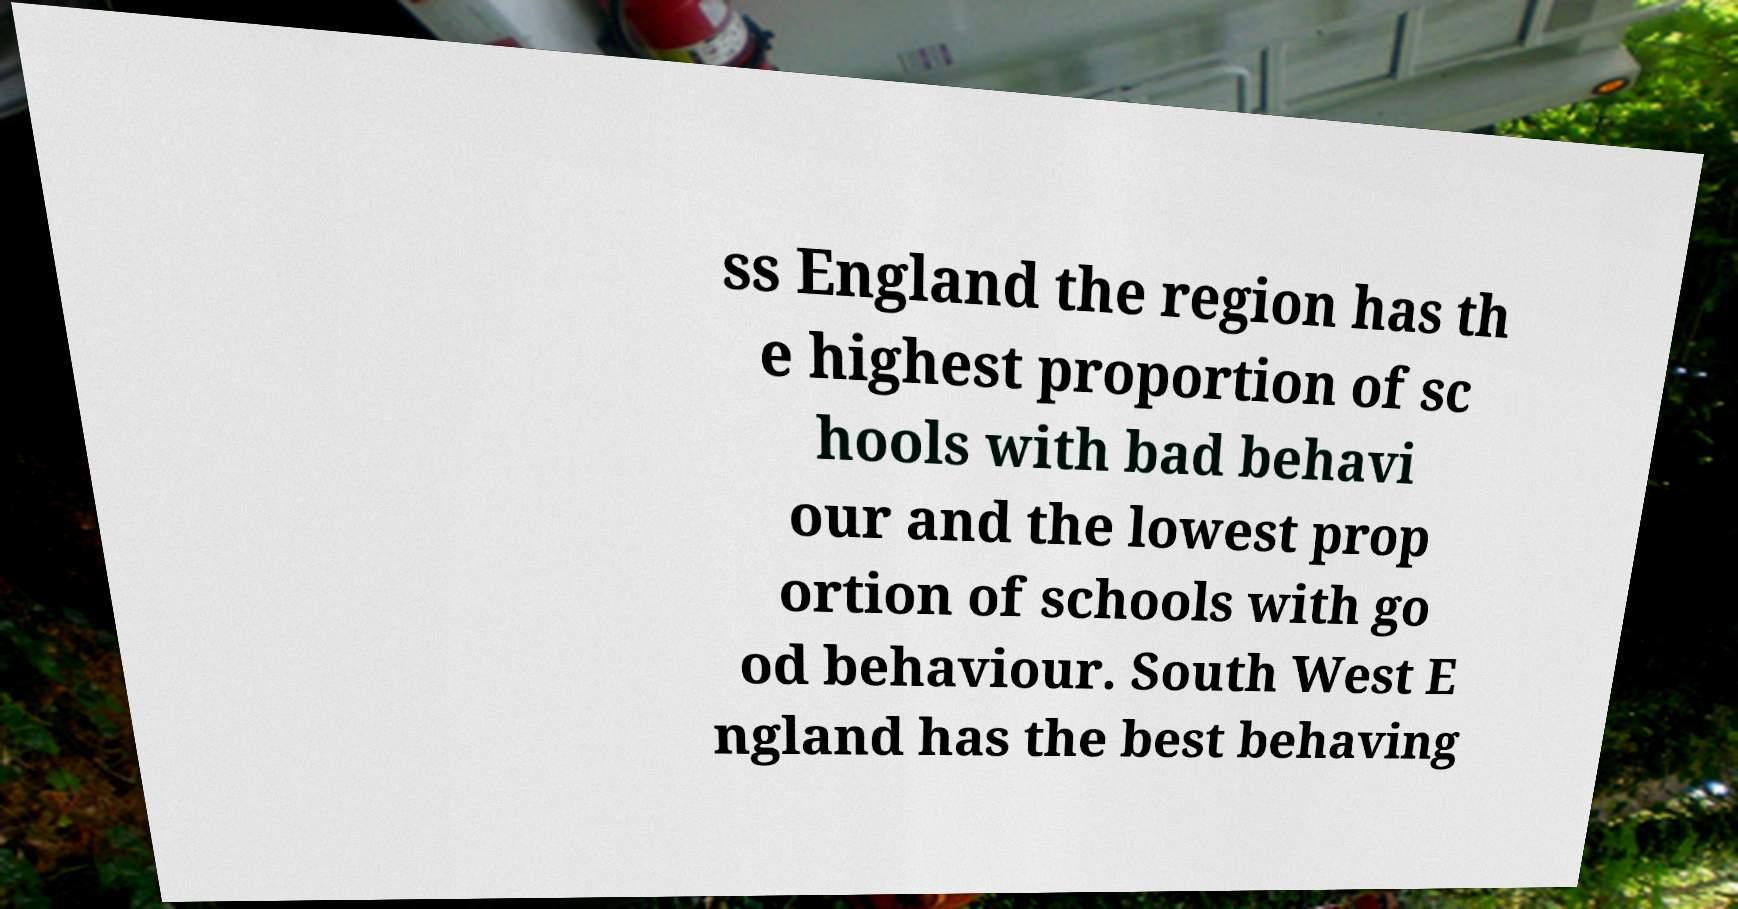Please identify and transcribe the text found in this image. ss England the region has th e highest proportion of sc hools with bad behavi our and the lowest prop ortion of schools with go od behaviour. South West E ngland has the best behaving 